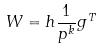Convert formula to latex. <formula><loc_0><loc_0><loc_500><loc_500>W = h \frac { 1 } { p ^ { k } } g ^ { T }</formula> 